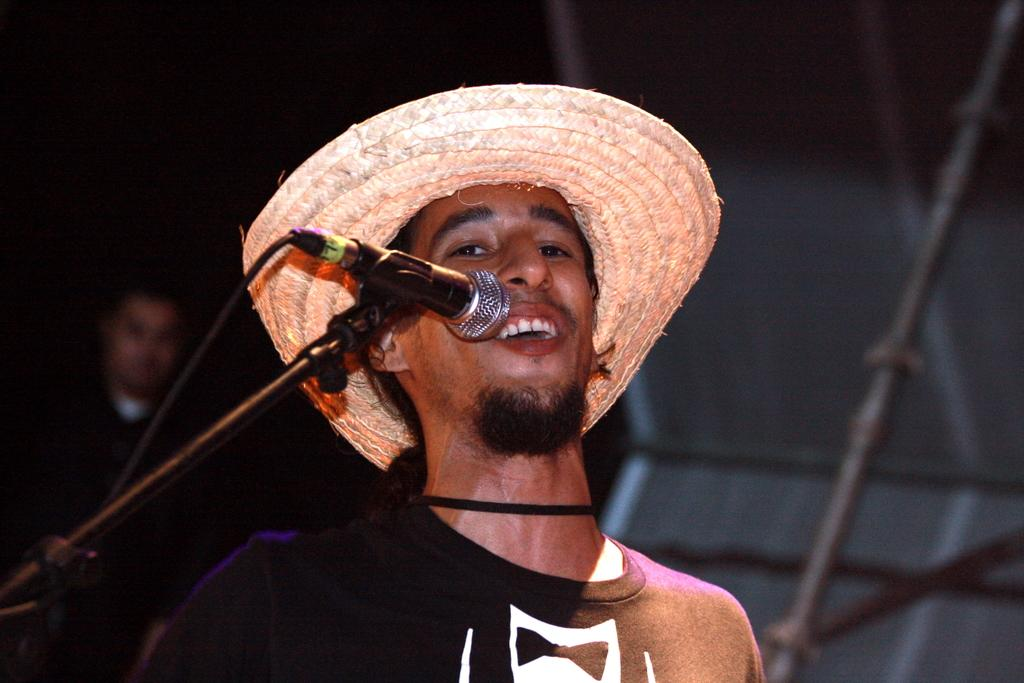What is the main subject of the image? There is a person in the image. What is the person holding? The person is holding a mic. What is the person with the mic doing? The person holding the mic appears to be singing. Are there any other people in the image? Yes, there is another person in the image. Can you describe the background of the image? The background of the image is blurred. What type of lunch is being served in the image? There is no lunch present in the image. What is the level of friction between the person holding the mic and the microphone? The level of friction between the person holding the mic and the microphone cannot be determined from the image. 